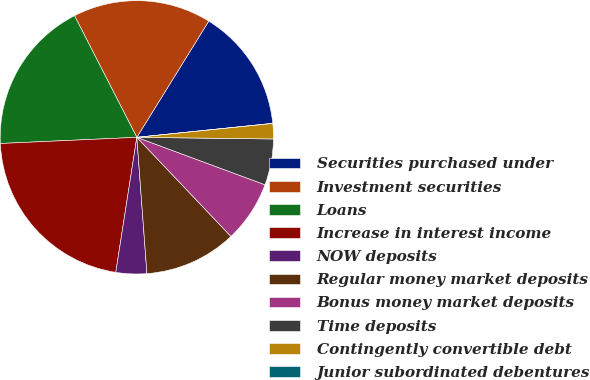<chart> <loc_0><loc_0><loc_500><loc_500><pie_chart><fcel>Securities purchased under<fcel>Investment securities<fcel>Loans<fcel>Increase in interest income<fcel>NOW deposits<fcel>Regular money market deposits<fcel>Bonus money market deposits<fcel>Time deposits<fcel>Contingently convertible debt<fcel>Junior subordinated debentures<nl><fcel>14.55%<fcel>16.36%<fcel>18.18%<fcel>21.82%<fcel>3.64%<fcel>10.91%<fcel>7.27%<fcel>5.45%<fcel>1.82%<fcel>0.0%<nl></chart> 